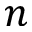<formula> <loc_0><loc_0><loc_500><loc_500>n</formula> 